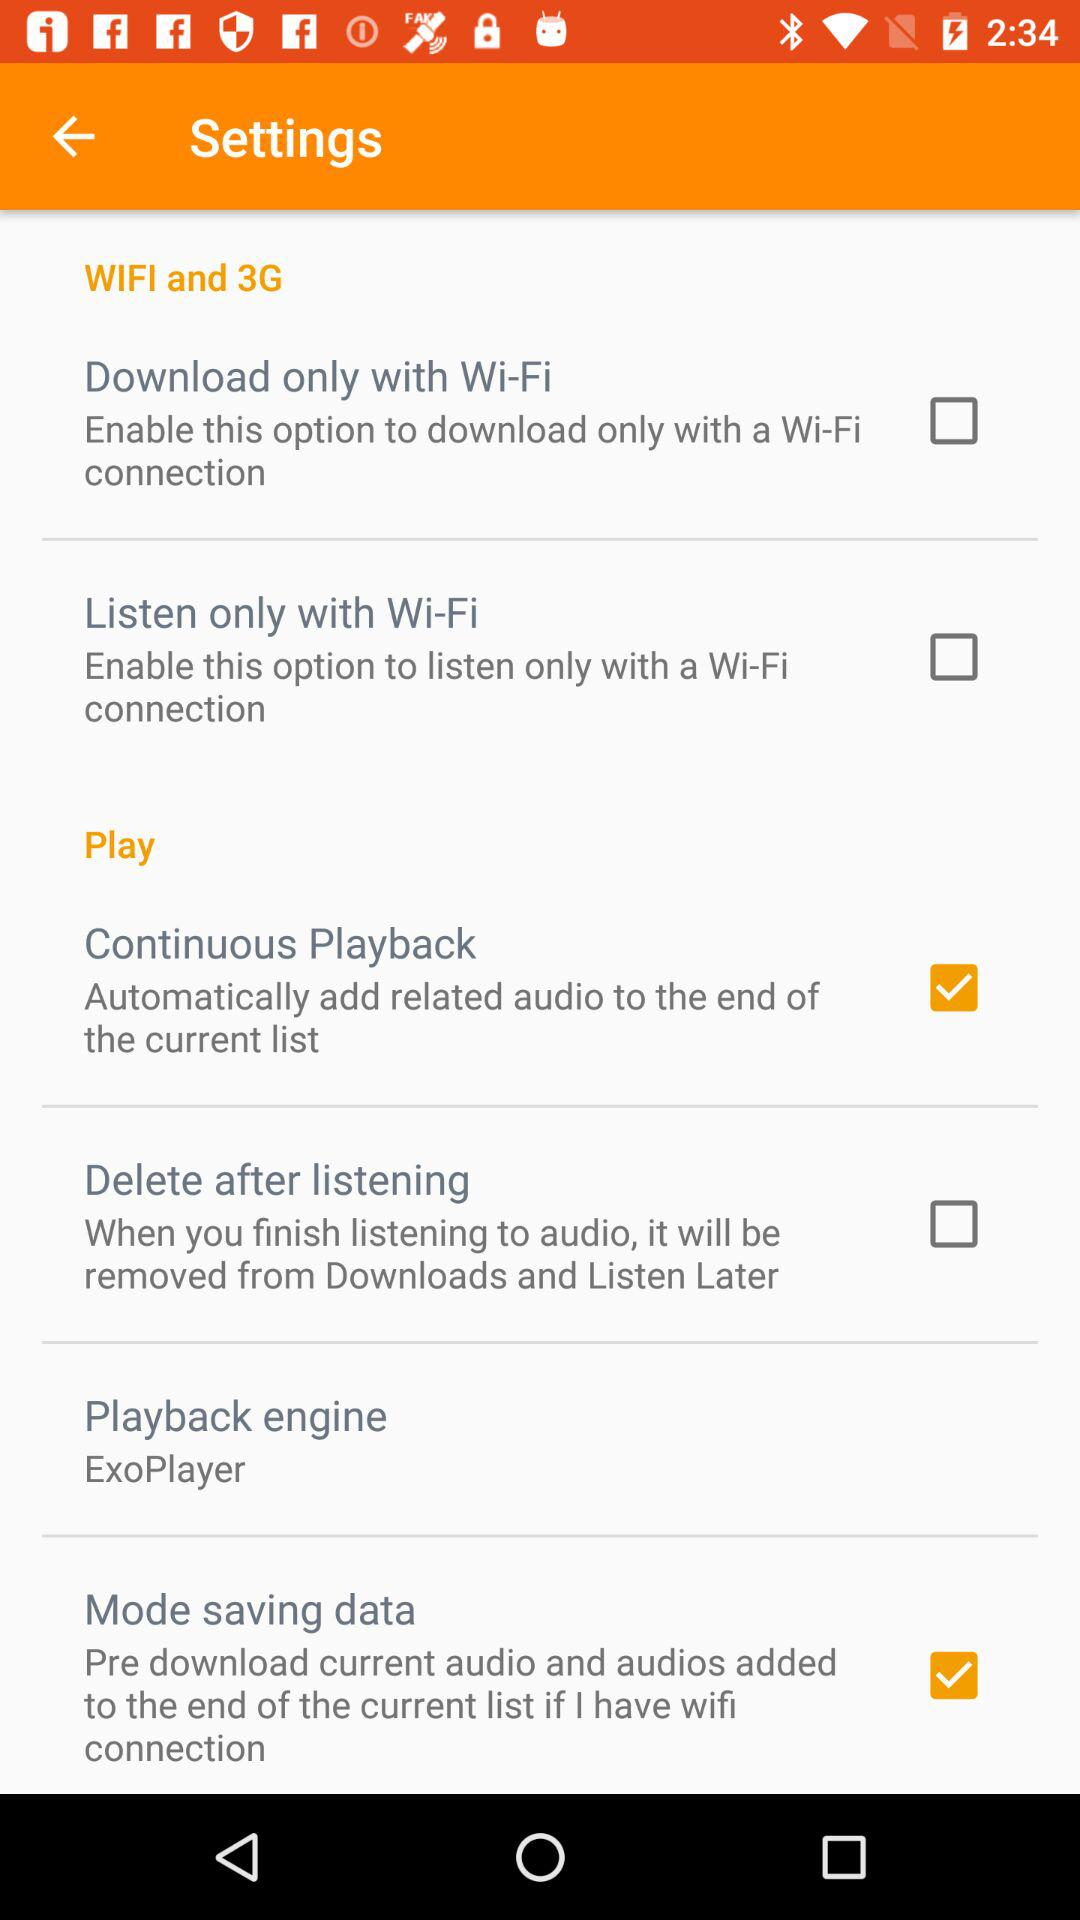What is the status of the "Download only with Wi-Fi"? The status of the "Download only with Wi-Fi" is "off". 